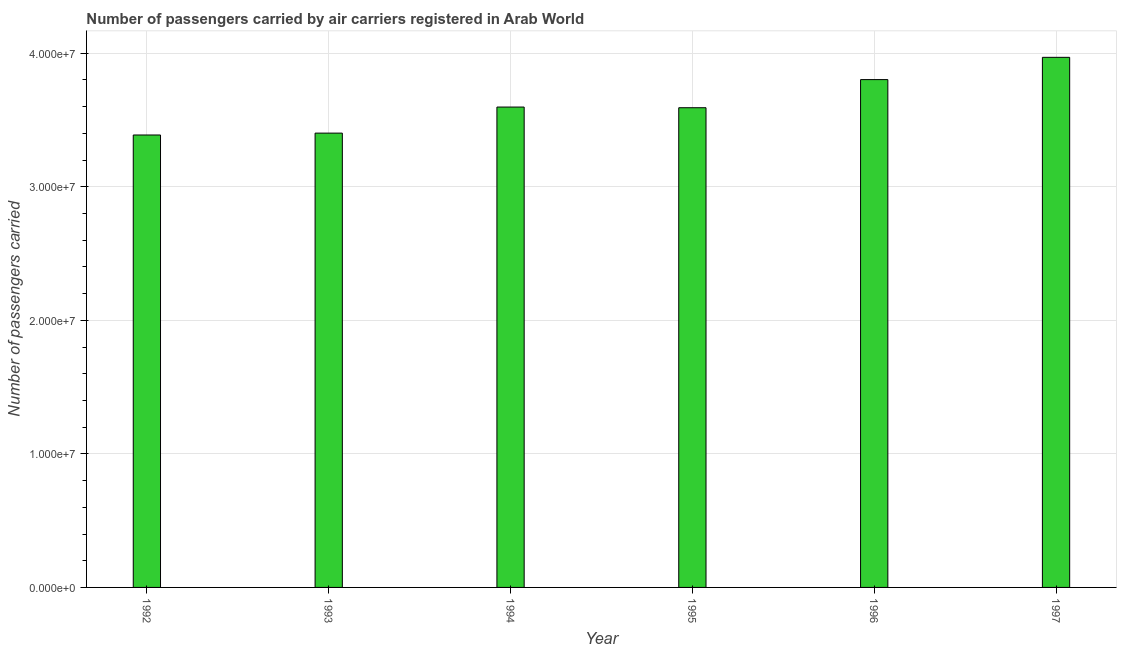Does the graph contain any zero values?
Your answer should be compact. No. Does the graph contain grids?
Offer a very short reply. Yes. What is the title of the graph?
Your answer should be very brief. Number of passengers carried by air carriers registered in Arab World. What is the label or title of the Y-axis?
Your answer should be very brief. Number of passengers carried. What is the number of passengers carried in 1995?
Offer a very short reply. 3.59e+07. Across all years, what is the maximum number of passengers carried?
Provide a succinct answer. 3.97e+07. Across all years, what is the minimum number of passengers carried?
Give a very brief answer. 3.39e+07. In which year was the number of passengers carried maximum?
Provide a succinct answer. 1997. What is the sum of the number of passengers carried?
Offer a terse response. 2.17e+08. What is the difference between the number of passengers carried in 1993 and 1996?
Your answer should be compact. -4.01e+06. What is the average number of passengers carried per year?
Offer a very short reply. 3.62e+07. What is the median number of passengers carried?
Ensure brevity in your answer.  3.59e+07. Do a majority of the years between 1992 and 1994 (inclusive) have number of passengers carried greater than 38000000 ?
Your response must be concise. No. What is the ratio of the number of passengers carried in 1995 to that in 1996?
Your response must be concise. 0.94. What is the difference between the highest and the second highest number of passengers carried?
Ensure brevity in your answer.  1.67e+06. What is the difference between the highest and the lowest number of passengers carried?
Ensure brevity in your answer.  5.82e+06. What is the difference between two consecutive major ticks on the Y-axis?
Offer a terse response. 1.00e+07. What is the Number of passengers carried of 1992?
Offer a very short reply. 3.39e+07. What is the Number of passengers carried in 1993?
Give a very brief answer. 3.40e+07. What is the Number of passengers carried in 1994?
Provide a succinct answer. 3.60e+07. What is the Number of passengers carried of 1995?
Offer a terse response. 3.59e+07. What is the Number of passengers carried in 1996?
Ensure brevity in your answer.  3.80e+07. What is the Number of passengers carried of 1997?
Provide a short and direct response. 3.97e+07. What is the difference between the Number of passengers carried in 1992 and 1993?
Provide a succinct answer. -1.40e+05. What is the difference between the Number of passengers carried in 1992 and 1994?
Provide a short and direct response. -2.09e+06. What is the difference between the Number of passengers carried in 1992 and 1995?
Your answer should be compact. -2.04e+06. What is the difference between the Number of passengers carried in 1992 and 1996?
Your answer should be compact. -4.15e+06. What is the difference between the Number of passengers carried in 1992 and 1997?
Provide a short and direct response. -5.82e+06. What is the difference between the Number of passengers carried in 1993 and 1994?
Provide a succinct answer. -1.95e+06. What is the difference between the Number of passengers carried in 1993 and 1995?
Offer a very short reply. -1.90e+06. What is the difference between the Number of passengers carried in 1993 and 1996?
Provide a short and direct response. -4.01e+06. What is the difference between the Number of passengers carried in 1993 and 1997?
Keep it short and to the point. -5.67e+06. What is the difference between the Number of passengers carried in 1994 and 1995?
Keep it short and to the point. 5.01e+04. What is the difference between the Number of passengers carried in 1994 and 1996?
Ensure brevity in your answer.  -2.06e+06. What is the difference between the Number of passengers carried in 1994 and 1997?
Provide a short and direct response. -3.72e+06. What is the difference between the Number of passengers carried in 1995 and 1996?
Make the answer very short. -2.11e+06. What is the difference between the Number of passengers carried in 1995 and 1997?
Make the answer very short. -3.77e+06. What is the difference between the Number of passengers carried in 1996 and 1997?
Give a very brief answer. -1.67e+06. What is the ratio of the Number of passengers carried in 1992 to that in 1994?
Give a very brief answer. 0.94. What is the ratio of the Number of passengers carried in 1992 to that in 1995?
Your response must be concise. 0.94. What is the ratio of the Number of passengers carried in 1992 to that in 1996?
Keep it short and to the point. 0.89. What is the ratio of the Number of passengers carried in 1992 to that in 1997?
Keep it short and to the point. 0.85. What is the ratio of the Number of passengers carried in 1993 to that in 1994?
Your answer should be compact. 0.95. What is the ratio of the Number of passengers carried in 1993 to that in 1995?
Your response must be concise. 0.95. What is the ratio of the Number of passengers carried in 1993 to that in 1996?
Provide a succinct answer. 0.9. What is the ratio of the Number of passengers carried in 1993 to that in 1997?
Your answer should be compact. 0.86. What is the ratio of the Number of passengers carried in 1994 to that in 1996?
Provide a succinct answer. 0.95. What is the ratio of the Number of passengers carried in 1994 to that in 1997?
Ensure brevity in your answer.  0.91. What is the ratio of the Number of passengers carried in 1995 to that in 1996?
Provide a short and direct response. 0.94. What is the ratio of the Number of passengers carried in 1995 to that in 1997?
Offer a very short reply. 0.91. What is the ratio of the Number of passengers carried in 1996 to that in 1997?
Provide a short and direct response. 0.96. 